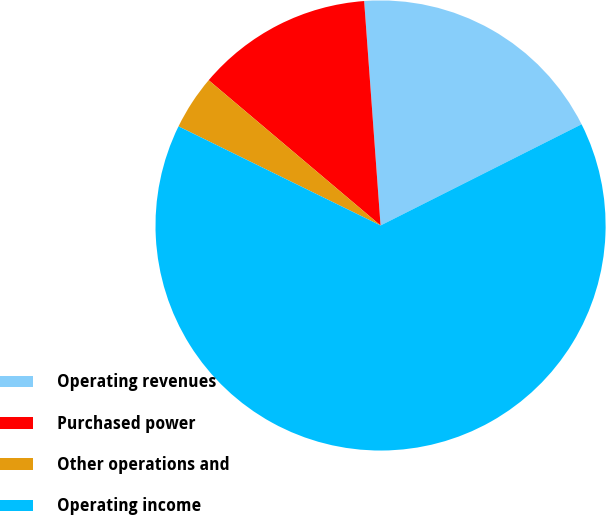Convert chart. <chart><loc_0><loc_0><loc_500><loc_500><pie_chart><fcel>Operating revenues<fcel>Purchased power<fcel>Other operations and<fcel>Operating income<nl><fcel>18.74%<fcel>12.67%<fcel>3.91%<fcel>64.68%<nl></chart> 